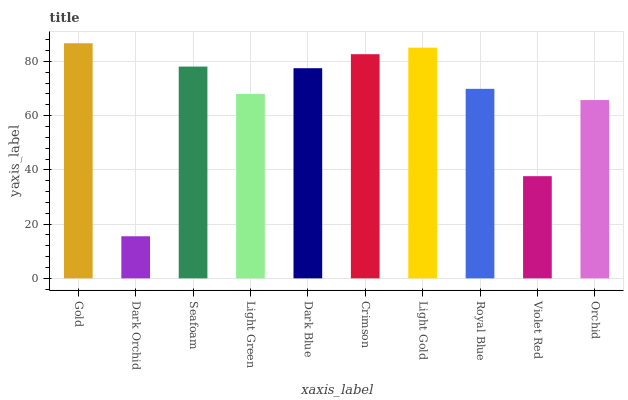Is Dark Orchid the minimum?
Answer yes or no. Yes. Is Gold the maximum?
Answer yes or no. Yes. Is Seafoam the minimum?
Answer yes or no. No. Is Seafoam the maximum?
Answer yes or no. No. Is Seafoam greater than Dark Orchid?
Answer yes or no. Yes. Is Dark Orchid less than Seafoam?
Answer yes or no. Yes. Is Dark Orchid greater than Seafoam?
Answer yes or no. No. Is Seafoam less than Dark Orchid?
Answer yes or no. No. Is Dark Blue the high median?
Answer yes or no. Yes. Is Royal Blue the low median?
Answer yes or no. Yes. Is Royal Blue the high median?
Answer yes or no. No. Is Dark Blue the low median?
Answer yes or no. No. 